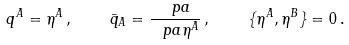Convert formula to latex. <formula><loc_0><loc_0><loc_500><loc_500>q ^ { A } = \eta ^ { A } \, , \quad \bar { q } _ { A } = \frac { \ p a } { \ p a \eta ^ { A } } \, , \quad \{ \eta ^ { A } , \eta ^ { B } \} = 0 \, .</formula> 